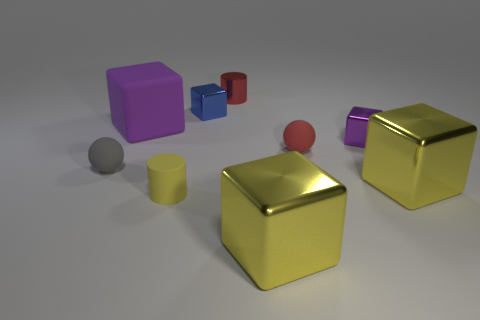What is the color of the large cube that is made of the same material as the small yellow thing?
Your answer should be compact. Purple. Do the small cylinder that is behind the small gray rubber thing and the tiny cylinder that is in front of the big matte cube have the same material?
Your response must be concise. No. Are there any things that have the same size as the gray rubber sphere?
Your answer should be very brief. Yes. There is a purple block left of the tiny red thing that is behind the small blue shiny block; what size is it?
Offer a terse response. Large. How many large things are the same color as the rubber cylinder?
Your answer should be compact. 2. What shape is the yellow shiny object in front of the metallic thing on the right side of the tiny purple metal block?
Your answer should be compact. Cube. What number of large yellow things have the same material as the small purple object?
Your answer should be very brief. 2. What is the material of the small cylinder that is in front of the tiny blue metal cube?
Your response must be concise. Rubber. The big object behind the gray matte object in front of the rubber ball that is behind the small gray object is what shape?
Provide a short and direct response. Cube. There is a rubber thing that is on the right side of the yellow cylinder; does it have the same color as the small metal cylinder behind the red rubber thing?
Ensure brevity in your answer.  Yes. 